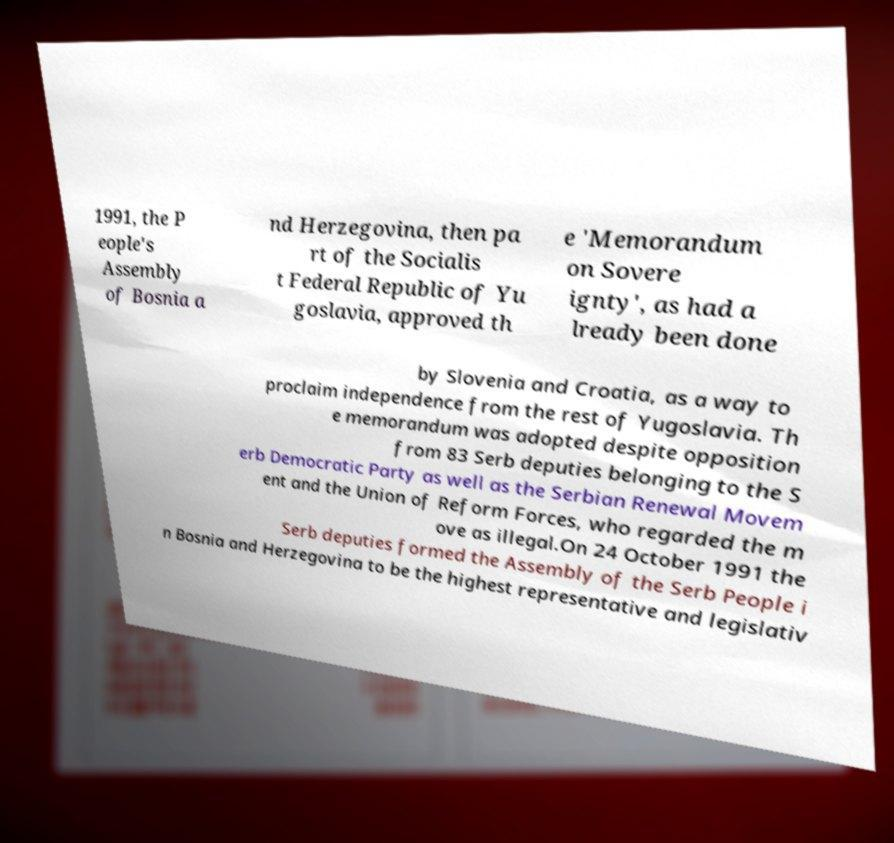I need the written content from this picture converted into text. Can you do that? 1991, the P eople's Assembly of Bosnia a nd Herzegovina, then pa rt of the Socialis t Federal Republic of Yu goslavia, approved th e 'Memorandum on Sovere ignty', as had a lready been done by Slovenia and Croatia, as a way to proclaim independence from the rest of Yugoslavia. Th e memorandum was adopted despite opposition from 83 Serb deputies belonging to the S erb Democratic Party as well as the Serbian Renewal Movem ent and the Union of Reform Forces, who regarded the m ove as illegal.On 24 October 1991 the Serb deputies formed the Assembly of the Serb People i n Bosnia and Herzegovina to be the highest representative and legislativ 